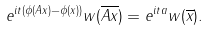<formula> <loc_0><loc_0><loc_500><loc_500>e ^ { i t \left ( \phi ( A x ) - \phi ( x ) \right ) } w ( \overline { A x } ) = e ^ { i t a } w ( \overline { x } ) .</formula> 